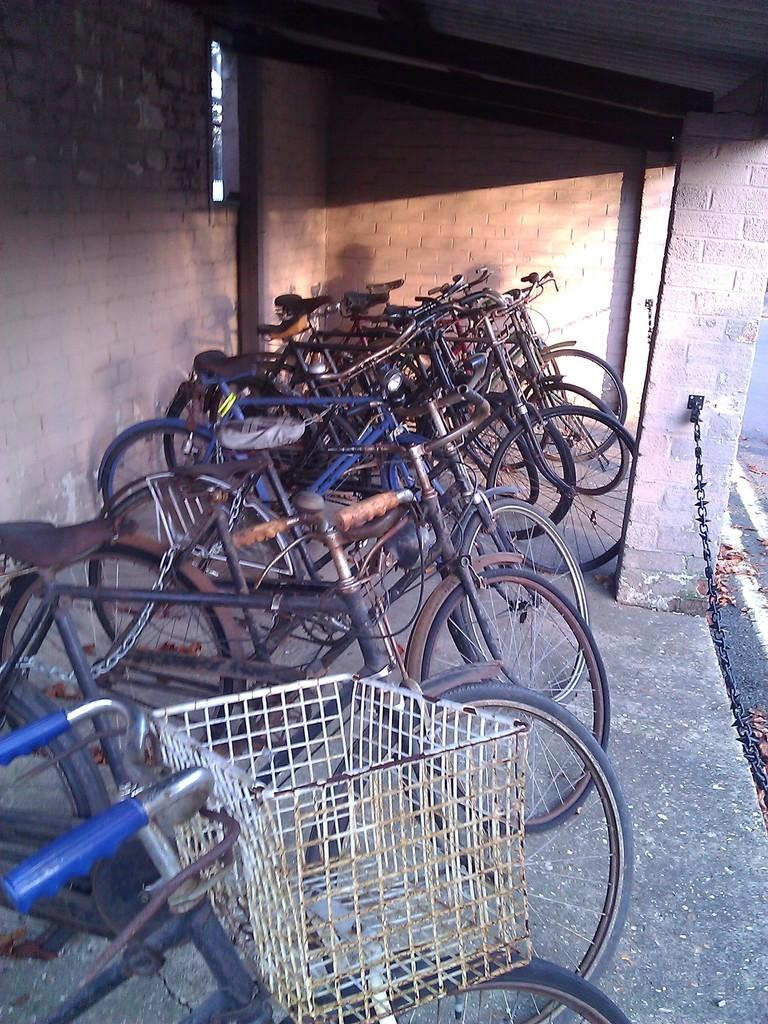What type of vehicles are parked in the image? There are cycles parked in the image. What can be seen in the background of the image? There is a wall visible in the image. What is the color of the wall in the image? The wall is in brown color. How many pears are hanging from the wall in the image? There are no pears present in the image; the wall is in brown color. 